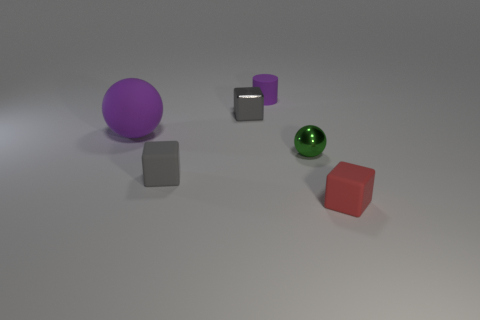Subtract all brown balls. How many gray cubes are left? 2 Subtract all gray cubes. How many cubes are left? 1 Subtract all yellow cubes. Subtract all cyan spheres. How many cubes are left? 3 Add 4 big matte things. How many objects exist? 10 Subtract 1 gray blocks. How many objects are left? 5 Subtract all balls. How many objects are left? 4 Subtract all small red rubber cubes. Subtract all purple objects. How many objects are left? 3 Add 2 small gray rubber things. How many small gray rubber things are left? 3 Add 1 big brown cubes. How many big brown cubes exist? 1 